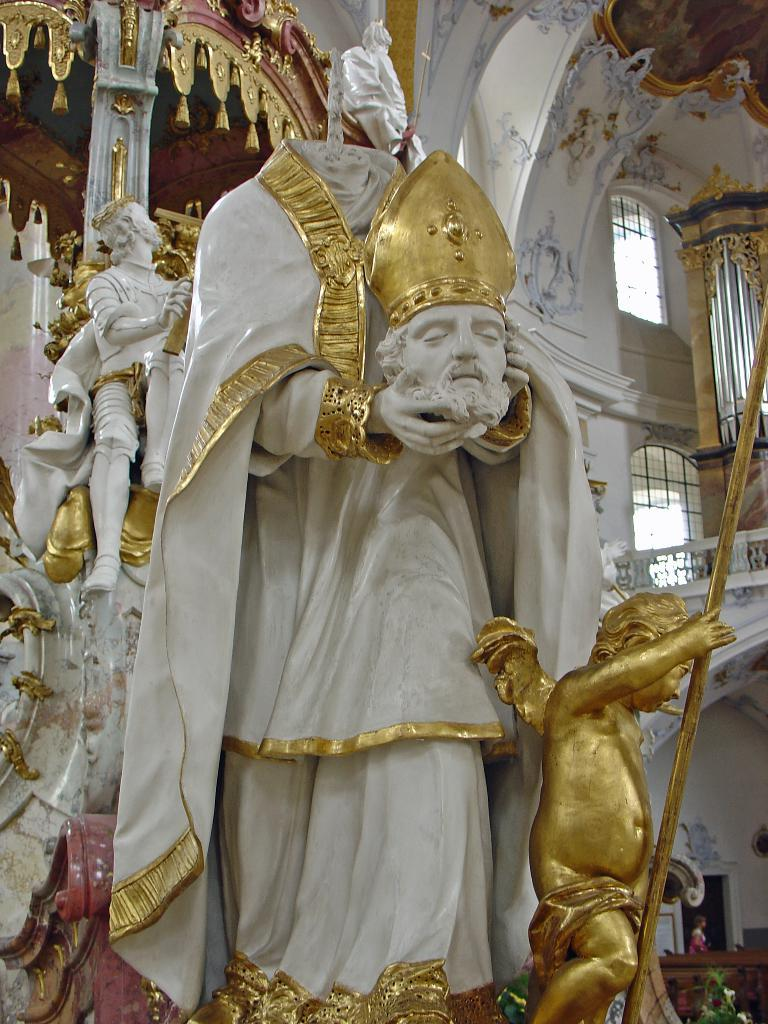What is the main subject in the center of the image? There is a statue in the center of the image. What can be seen in the background of the image? There are statues, windows, a door, a person, and a wall in the background of the image. How many statues are visible in the image? There is one statue in the center and additional statues in the background, so there are at least two statues visible. What type of wealth can be seen hanging from the swing in the image? There is no swing present in the image, so it is not possible to determine what type of wealth might be hanging from it. 